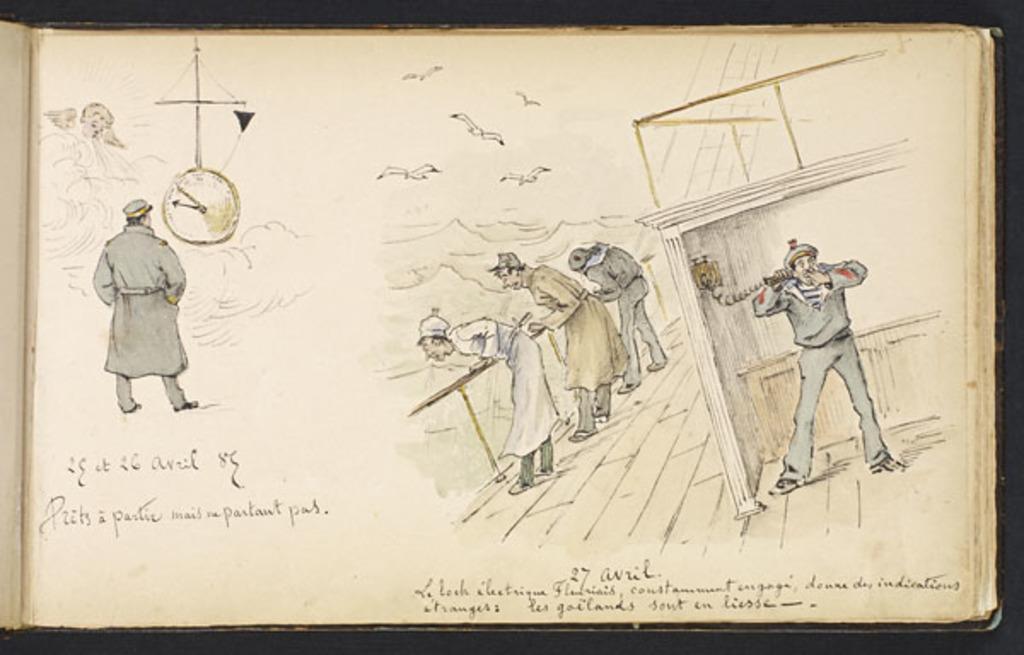Describe this image in one or two sentences. It is a painting inside the page of a book, there are three men standing on the floor and looking downwards and on the right side another person is talking on a phone ,on the left side there is a person standing in front of a clock and there are some birds flying in the air, below the pictures there is some information mentioned about the picture. 